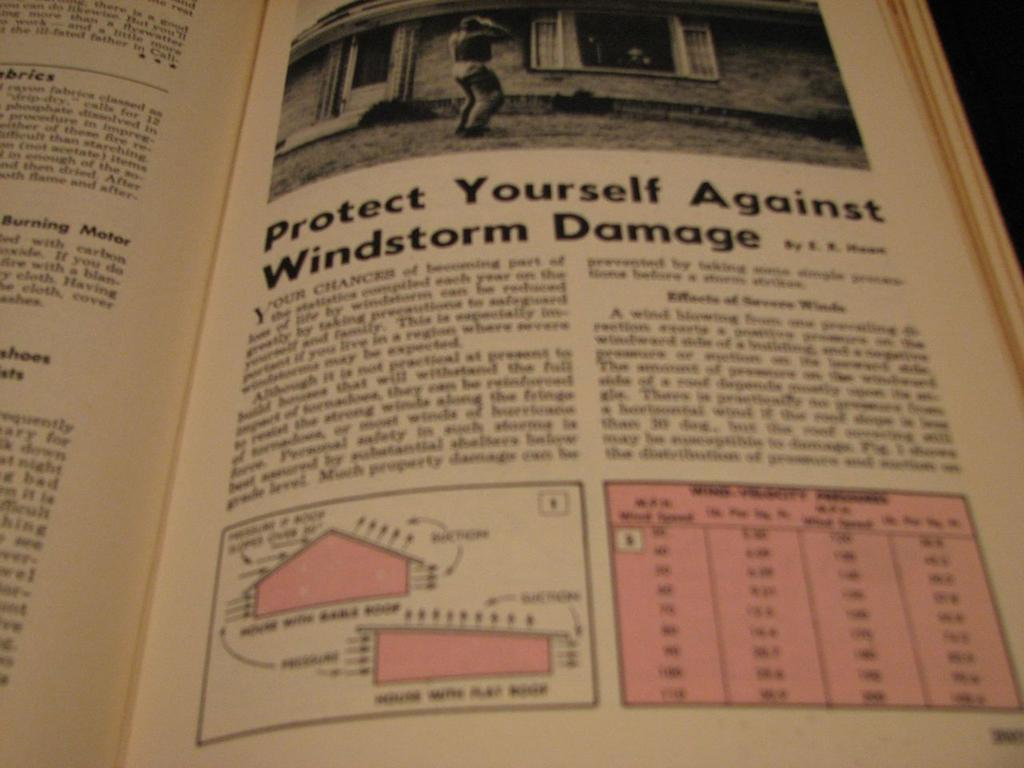<image>
Give a short and clear explanation of the subsequent image. A book with information regarding protecting yourself against windstorm damage 